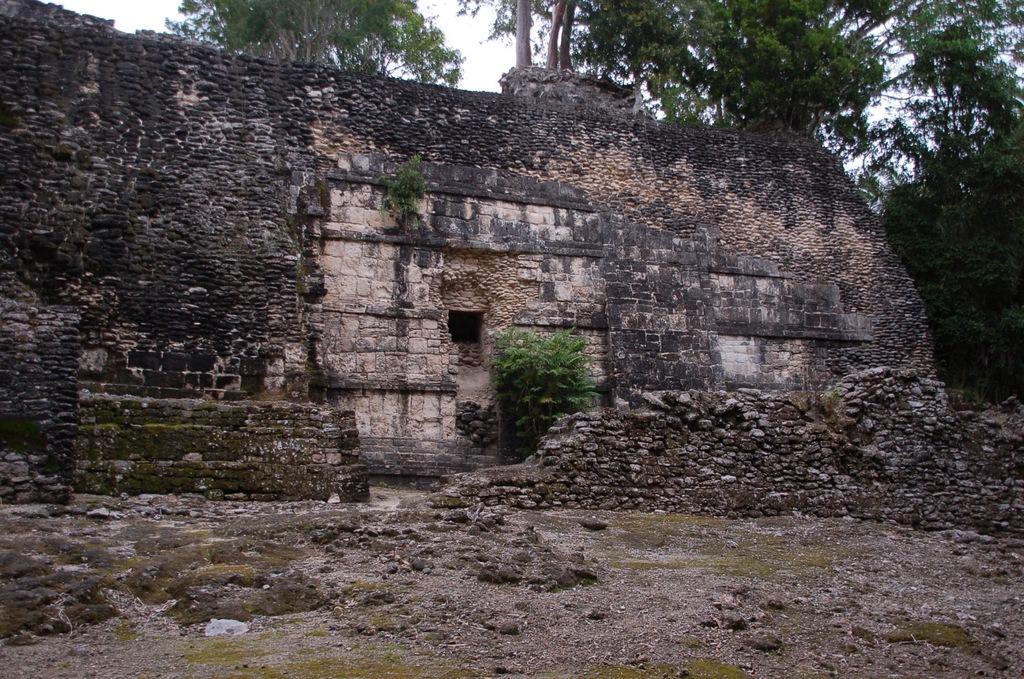Please provide a concise description of this image. In the center of the image, we can see an old building and in the background, there are trees. At the bottom, there is ground. 